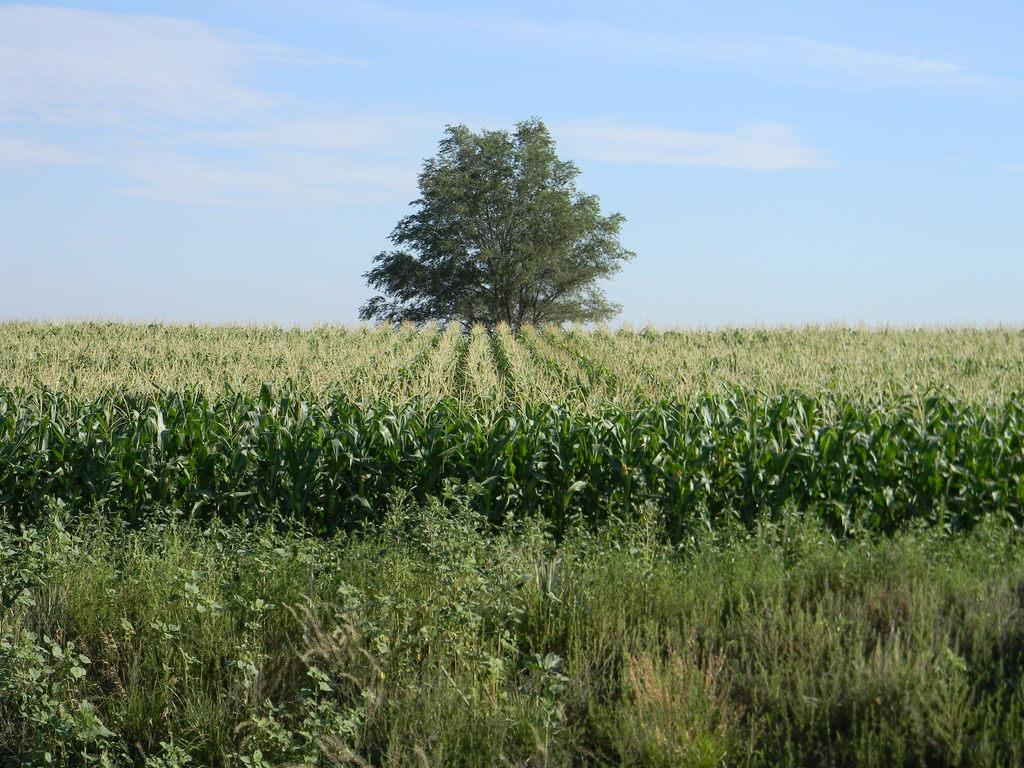What can be seen in the foreground of the image? There are crops in the foreground of the image. What is located in the background of the image? There is a tree in the background of the image. What else is visible in the background of the image? The sky is visible in the background of the image. What type of nut is hanging from the tree in the image? There is no nut hanging from the tree in the image; only the tree and crops are present. What grade is the tree in the image? The tree in the image is not assigned a grade, as it is a natural object and not a student or subject being evaluated. 